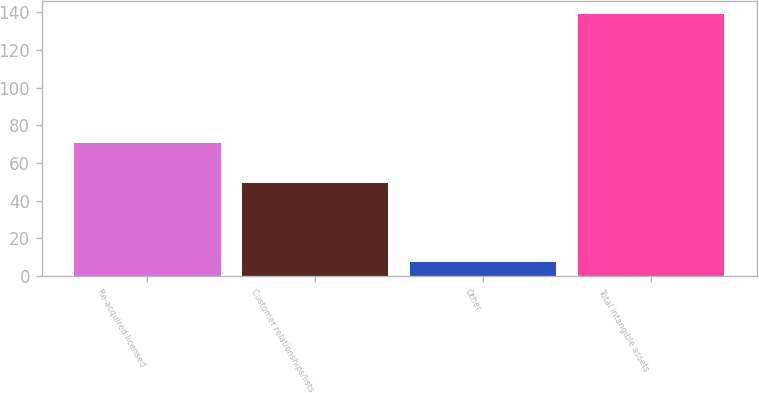Convert chart. <chart><loc_0><loc_0><loc_500><loc_500><bar_chart><fcel>Re-acquired licensed<fcel>Customer relationships/lists<fcel>Other<fcel>Total intangible assets<nl><fcel>70.6<fcel>49.3<fcel>7.2<fcel>139.09<nl></chart> 